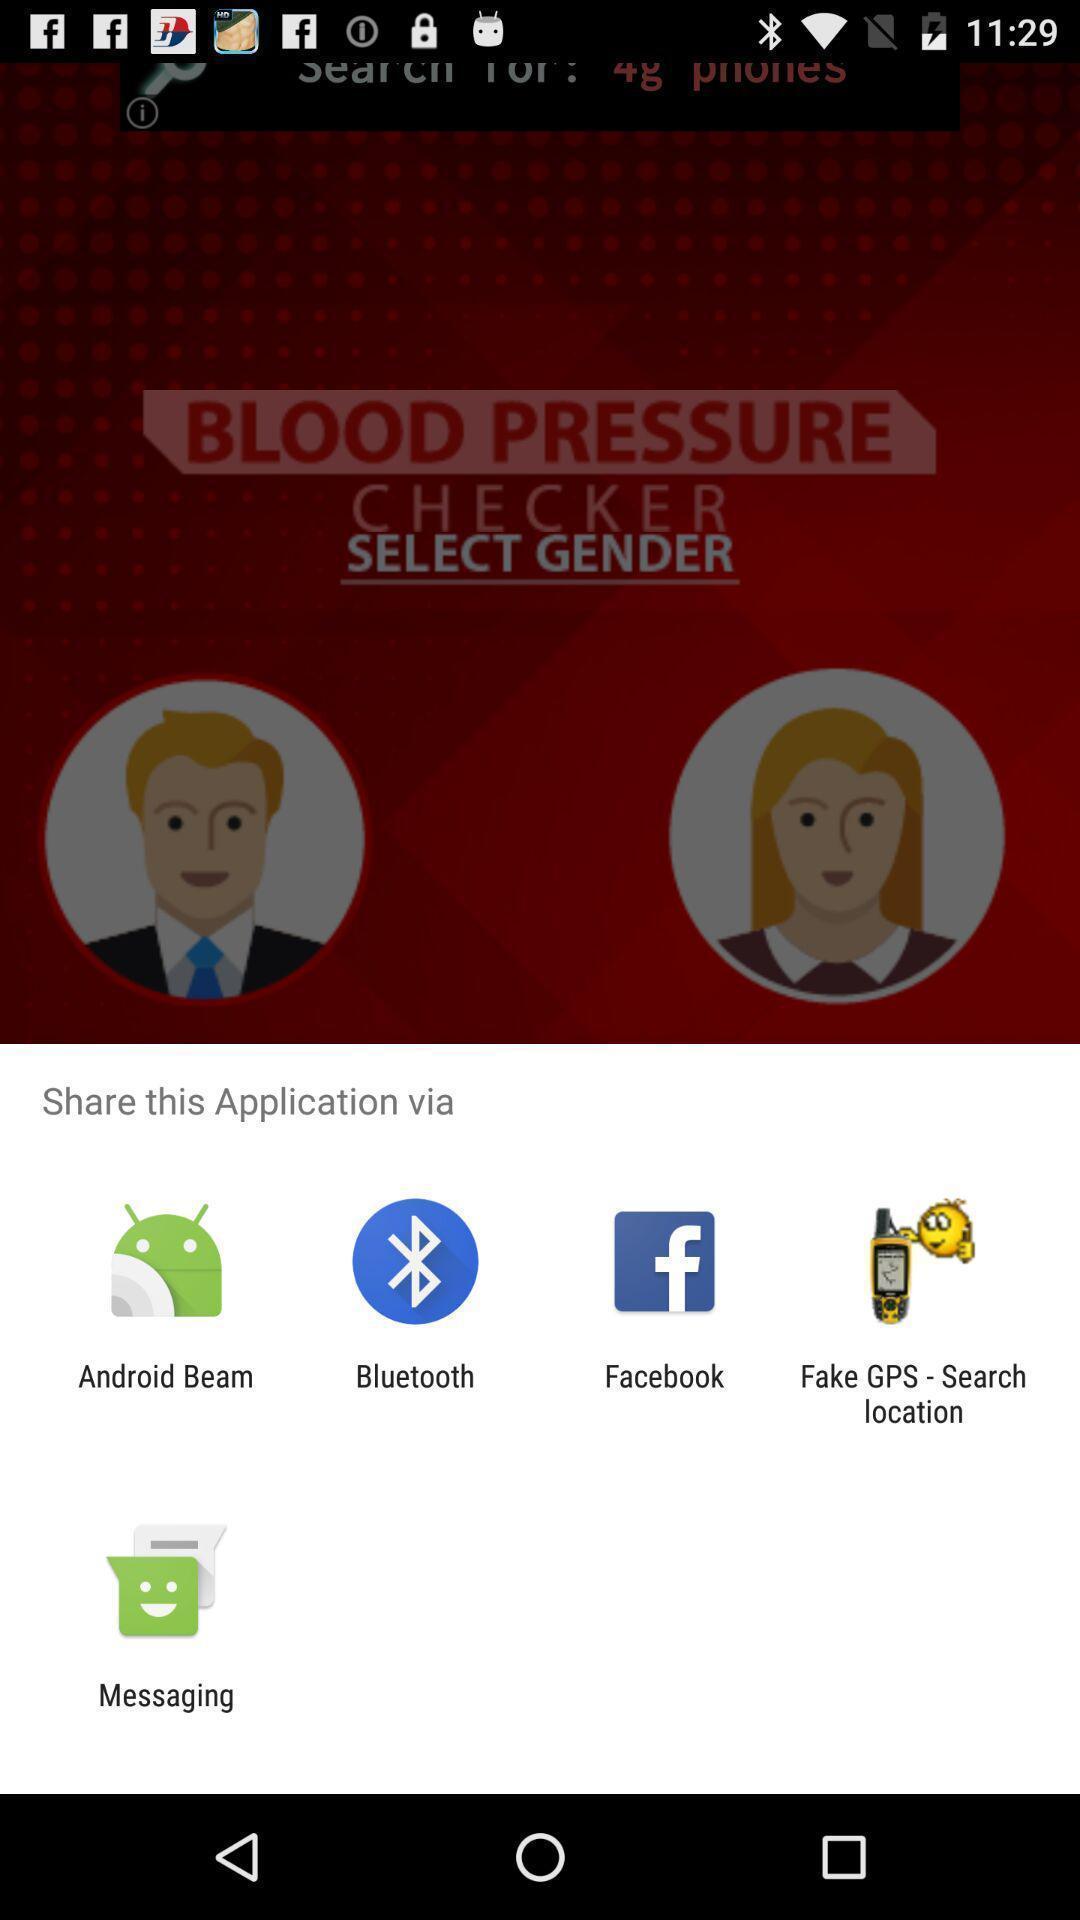Summarize the main components in this picture. Push up message with multiple sharing options. 